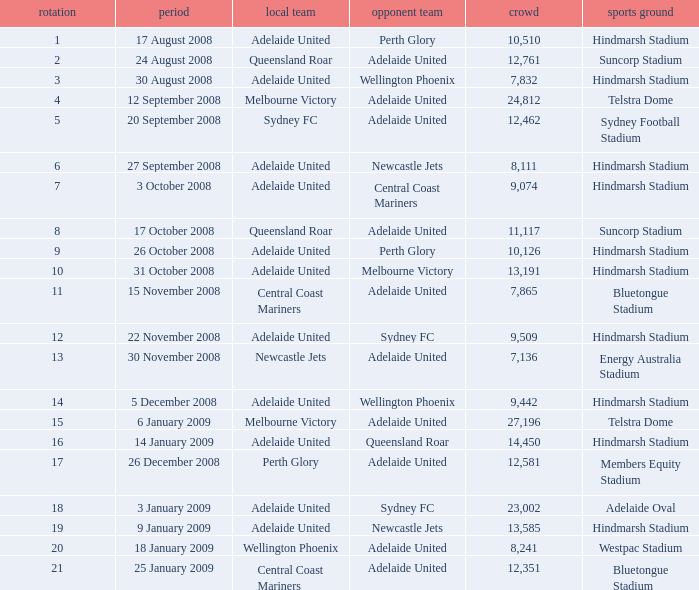Write the full table. {'header': ['rotation', 'period', 'local team', 'opponent team', 'crowd', 'sports ground'], 'rows': [['1', '17 August 2008', 'Adelaide United', 'Perth Glory', '10,510', 'Hindmarsh Stadium'], ['2', '24 August 2008', 'Queensland Roar', 'Adelaide United', '12,761', 'Suncorp Stadium'], ['3', '30 August 2008', 'Adelaide United', 'Wellington Phoenix', '7,832', 'Hindmarsh Stadium'], ['4', '12 September 2008', 'Melbourne Victory', 'Adelaide United', '24,812', 'Telstra Dome'], ['5', '20 September 2008', 'Sydney FC', 'Adelaide United', '12,462', 'Sydney Football Stadium'], ['6', '27 September 2008', 'Adelaide United', 'Newcastle Jets', '8,111', 'Hindmarsh Stadium'], ['7', '3 October 2008', 'Adelaide United', 'Central Coast Mariners', '9,074', 'Hindmarsh Stadium'], ['8', '17 October 2008', 'Queensland Roar', 'Adelaide United', '11,117', 'Suncorp Stadium'], ['9', '26 October 2008', 'Adelaide United', 'Perth Glory', '10,126', 'Hindmarsh Stadium'], ['10', '31 October 2008', 'Adelaide United', 'Melbourne Victory', '13,191', 'Hindmarsh Stadium'], ['11', '15 November 2008', 'Central Coast Mariners', 'Adelaide United', '7,865', 'Bluetongue Stadium'], ['12', '22 November 2008', 'Adelaide United', 'Sydney FC', '9,509', 'Hindmarsh Stadium'], ['13', '30 November 2008', 'Newcastle Jets', 'Adelaide United', '7,136', 'Energy Australia Stadium'], ['14', '5 December 2008', 'Adelaide United', 'Wellington Phoenix', '9,442', 'Hindmarsh Stadium'], ['15', '6 January 2009', 'Melbourne Victory', 'Adelaide United', '27,196', 'Telstra Dome'], ['16', '14 January 2009', 'Adelaide United', 'Queensland Roar', '14,450', 'Hindmarsh Stadium'], ['17', '26 December 2008', 'Perth Glory', 'Adelaide United', '12,581', 'Members Equity Stadium'], ['18', '3 January 2009', 'Adelaide United', 'Sydney FC', '23,002', 'Adelaide Oval'], ['19', '9 January 2009', 'Adelaide United', 'Newcastle Jets', '13,585', 'Hindmarsh Stadium'], ['20', '18 January 2009', 'Wellington Phoenix', 'Adelaide United', '8,241', 'Westpac Stadium'], ['21', '25 January 2009', 'Central Coast Mariners', 'Adelaide United', '12,351', 'Bluetongue Stadium']]} What is the least round for the game played at Members Equity Stadium in from of 12,581 people? None. 